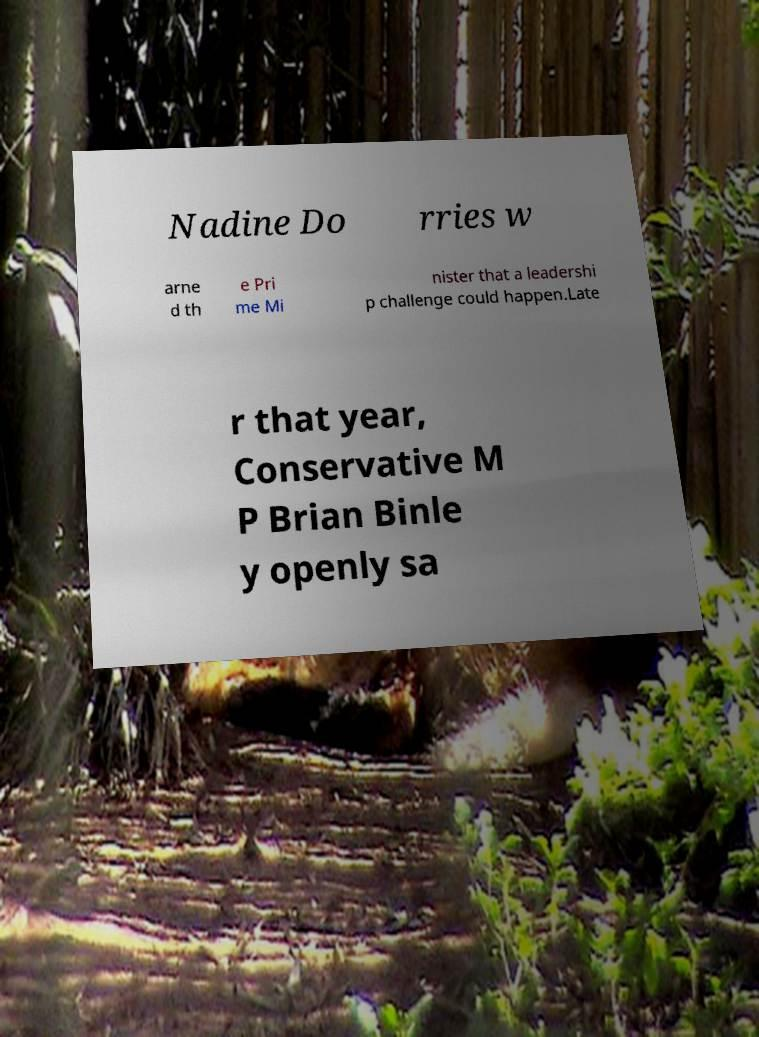Can you accurately transcribe the text from the provided image for me? Nadine Do rries w arne d th e Pri me Mi nister that a leadershi p challenge could happen.Late r that year, Conservative M P Brian Binle y openly sa 